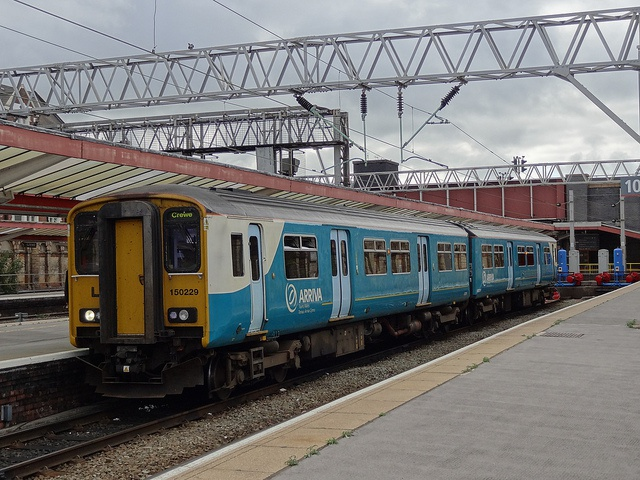Describe the objects in this image and their specific colors. I can see a train in lightgray, black, blue, darkgray, and gray tones in this image. 